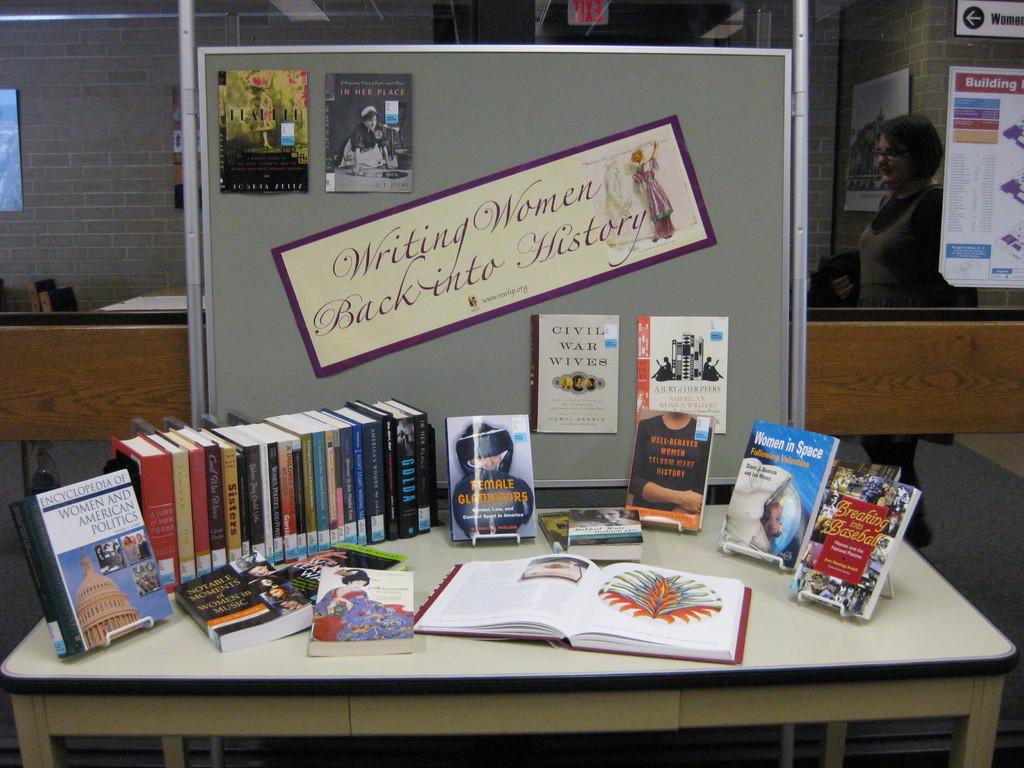What is the title of the book second from the end on the right?
Offer a terse response. Women in space. 